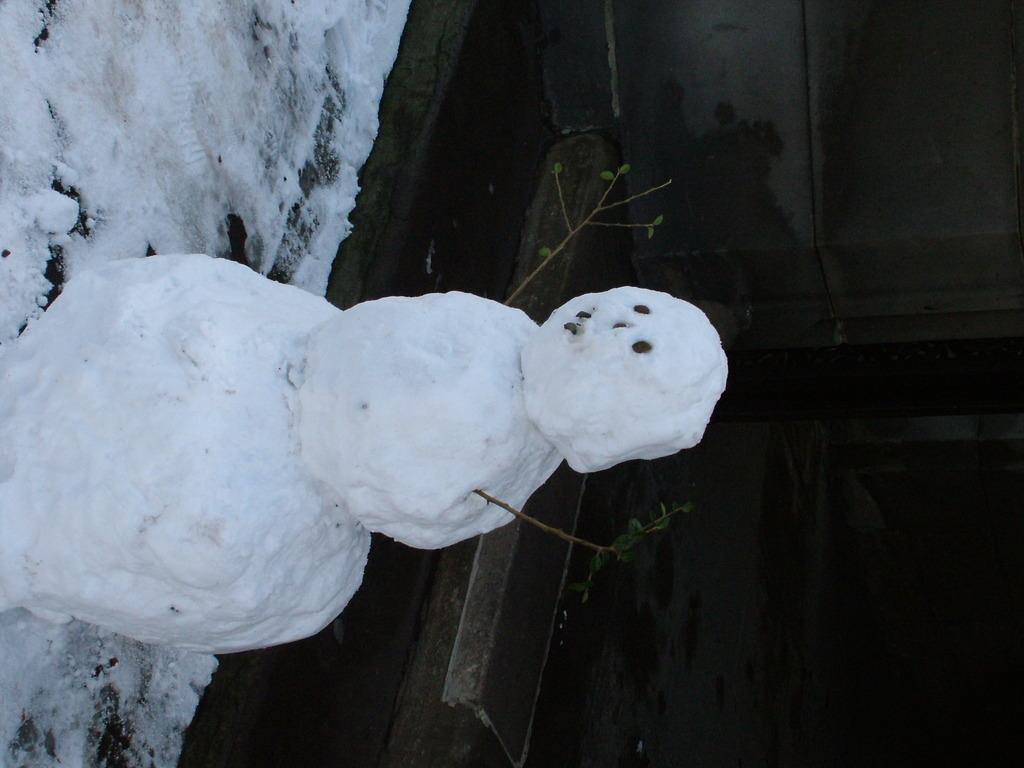What is the main subject of the image? There is a snowman in the image. What type of weather condition is depicted in the image? There is snow visible in the image. What can be observed about the background of the image? The background of the image is dark. What is the name of the governor who is present in the image? There is no governor present in the image; it features a snowman and snow. How many representatives can be seen in the image? There are no representatives present in the image. 